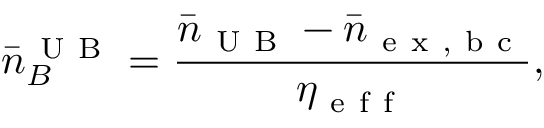Convert formula to latex. <formula><loc_0><loc_0><loc_500><loc_500>\bar { n } _ { B } ^ { U B } = \frac { \bar { n } _ { U B } - \bar { n } _ { e x , b c } } { \eta _ { e f f } } ,</formula> 